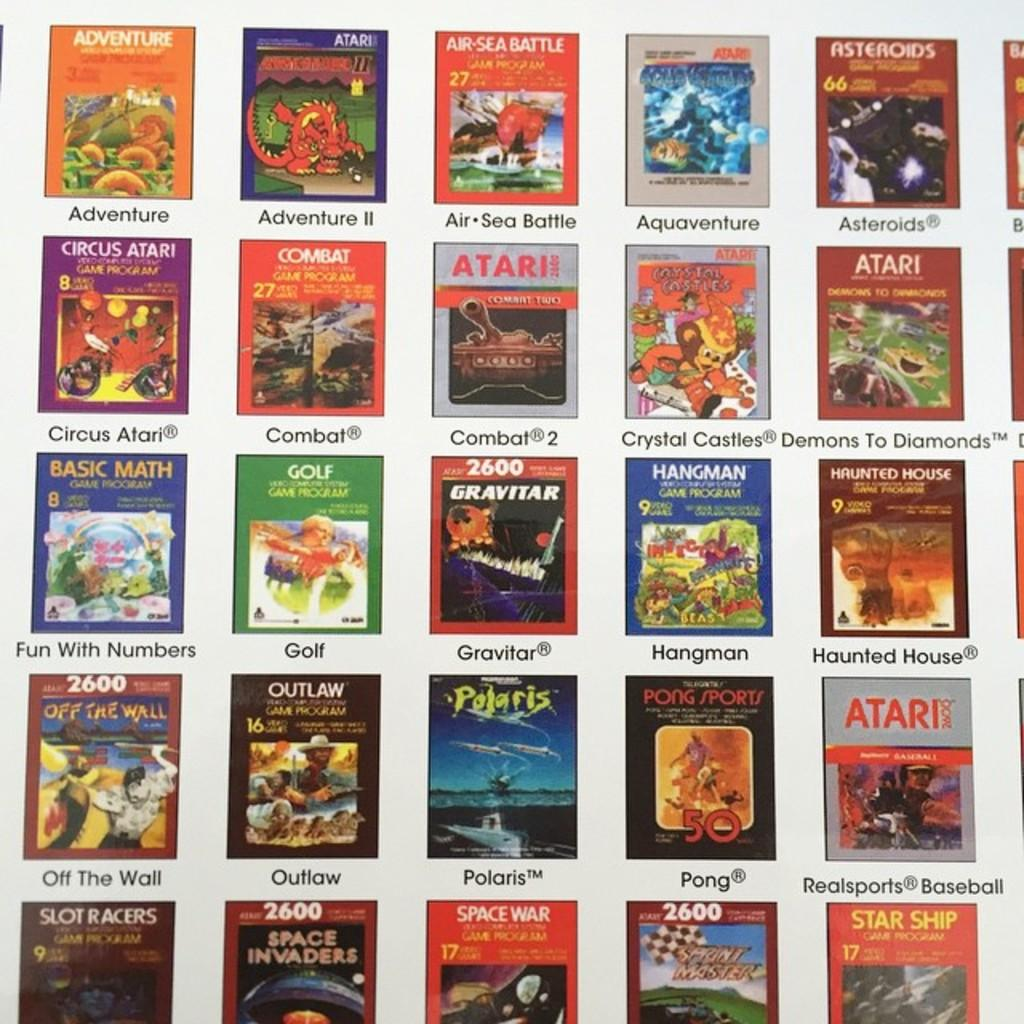<image>
Present a compact description of the photo's key features. Many different Atari video games against a white backdrop. 